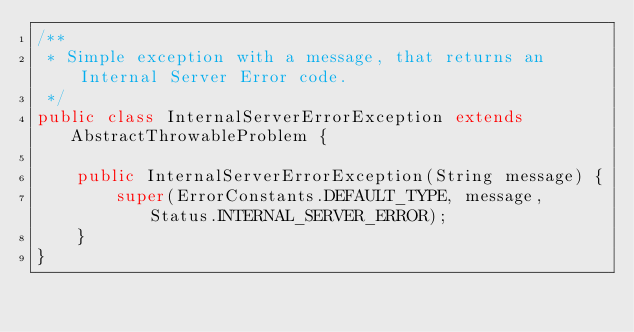Convert code to text. <code><loc_0><loc_0><loc_500><loc_500><_Java_>/**
 * Simple exception with a message, that returns an Internal Server Error code.
 */
public class InternalServerErrorException extends AbstractThrowableProblem {

    public InternalServerErrorException(String message) {
        super(ErrorConstants.DEFAULT_TYPE, message, Status.INTERNAL_SERVER_ERROR);
    }
}
</code> 